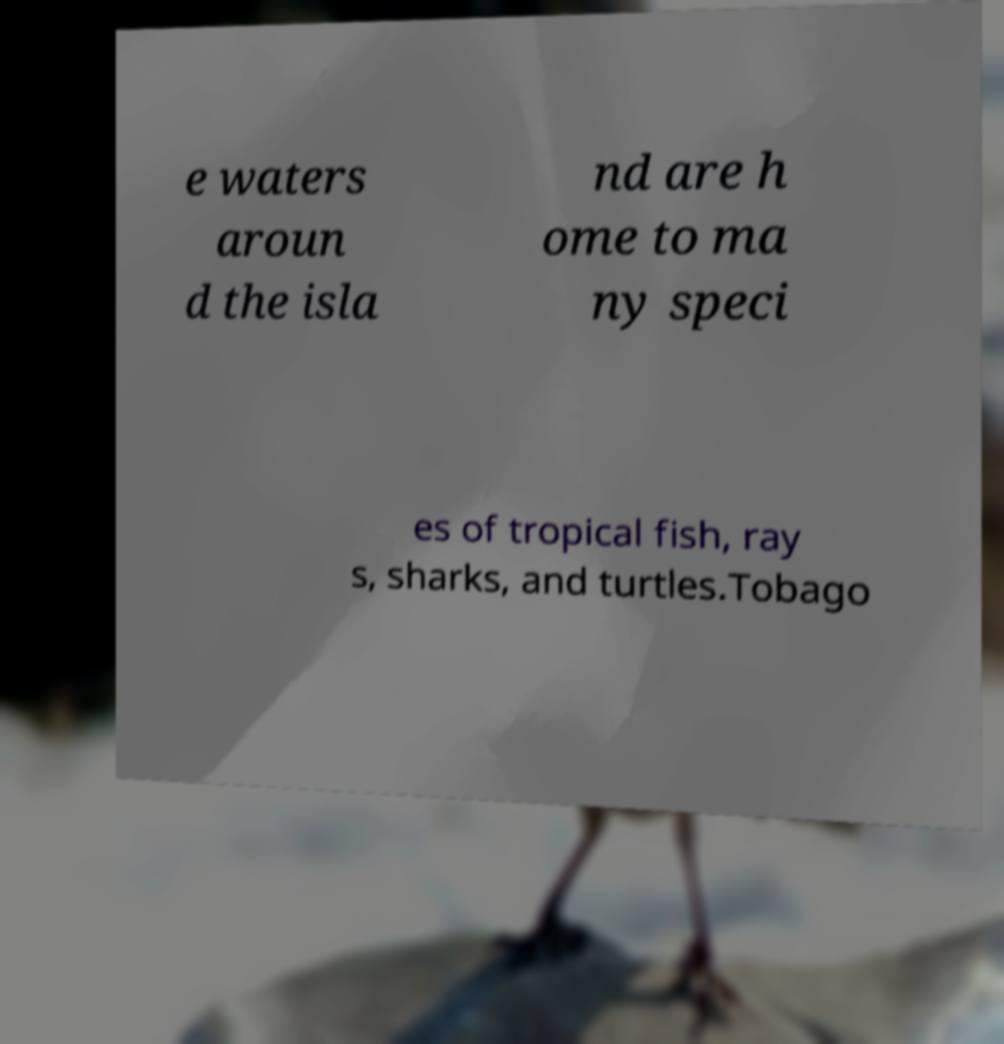I need the written content from this picture converted into text. Can you do that? e waters aroun d the isla nd are h ome to ma ny speci es of tropical fish, ray s, sharks, and turtles.Tobago 